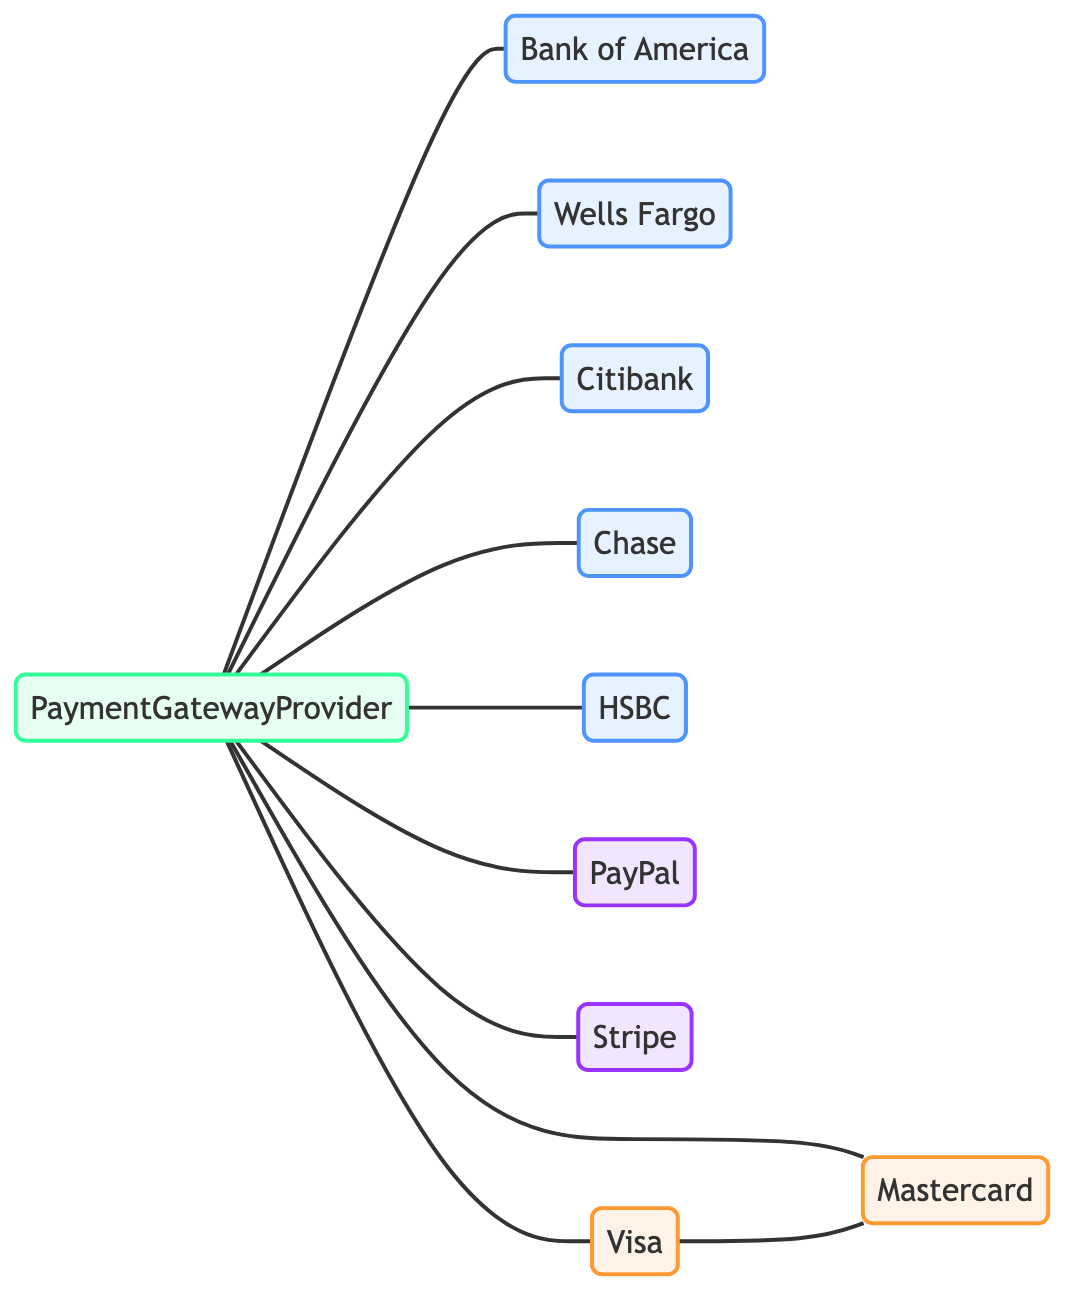What is the total number of nodes in the diagram? The diagram has a total of 10 nodes listed: Payment Gateway Provider, Bank of America, Wells Fargo, Citibank, Chase, HSBC, PayPal, Stripe, Visa, and Mastercard.
Answer: 10 How many edges are connected to the Payment Gateway Provider? The Payment Gateway Provider has 8 edges connecting it to other nodes, which are Bank of America, Wells Fargo, Citibank, Chase, HSBC, PayPal, Stripe, Visa, and Mastercard.
Answer: 8 Which node is connected to both Visa and Mastercard? The Visa and Mastercard nodes are directly connected to each other by an edge. There is no other node mentioned that connects both of them.
Answer: Visa and Mastercard Is Chase directly connected to any fintech company? Chase is not connected to any fintech nodes like PayPal or Stripe in the diagram, as all its connections are with banks and the Payment Gateway Provider.
Answer: No What type of nodes are connected to the Payment Gateway Provider? The nodes connected to the Payment Gateway Provider consist of banks (Bank of America, Wells Fargo, Citibank, Chase, HSBC), and fintech companies (PayPal, Stripe) as well as payment card networks (Visa, Mastercard).
Answer: Banks, Fintech companies, Card networks How many types of nodes are present in the diagram? In the diagram, there are four types of nodes: banks, fintech companies, payment card networks, and the payment gateway provider itself.
Answer: Four In total, how many edges connect the payment card networks? Visa and Mastercard have one direct edge connecting them, which is the only edge amongst the payment card networks in this graph.
Answer: One Which node is the central point of connections in the graph? The Payment Gateway Provider is the central node as it is connected to all other nodes, serving as the hub in this network.
Answer: Payment Gateway Provider Which bank does not connect to any payment card network? Among the banks represented, there are no direct connections from Bank of America, Wells Fargo, Citibank, Chase, or HSBC to any payment card networks like Visa or Mastercard, but they all connect to the Payment Gateway Provider.
Answer: All banks 